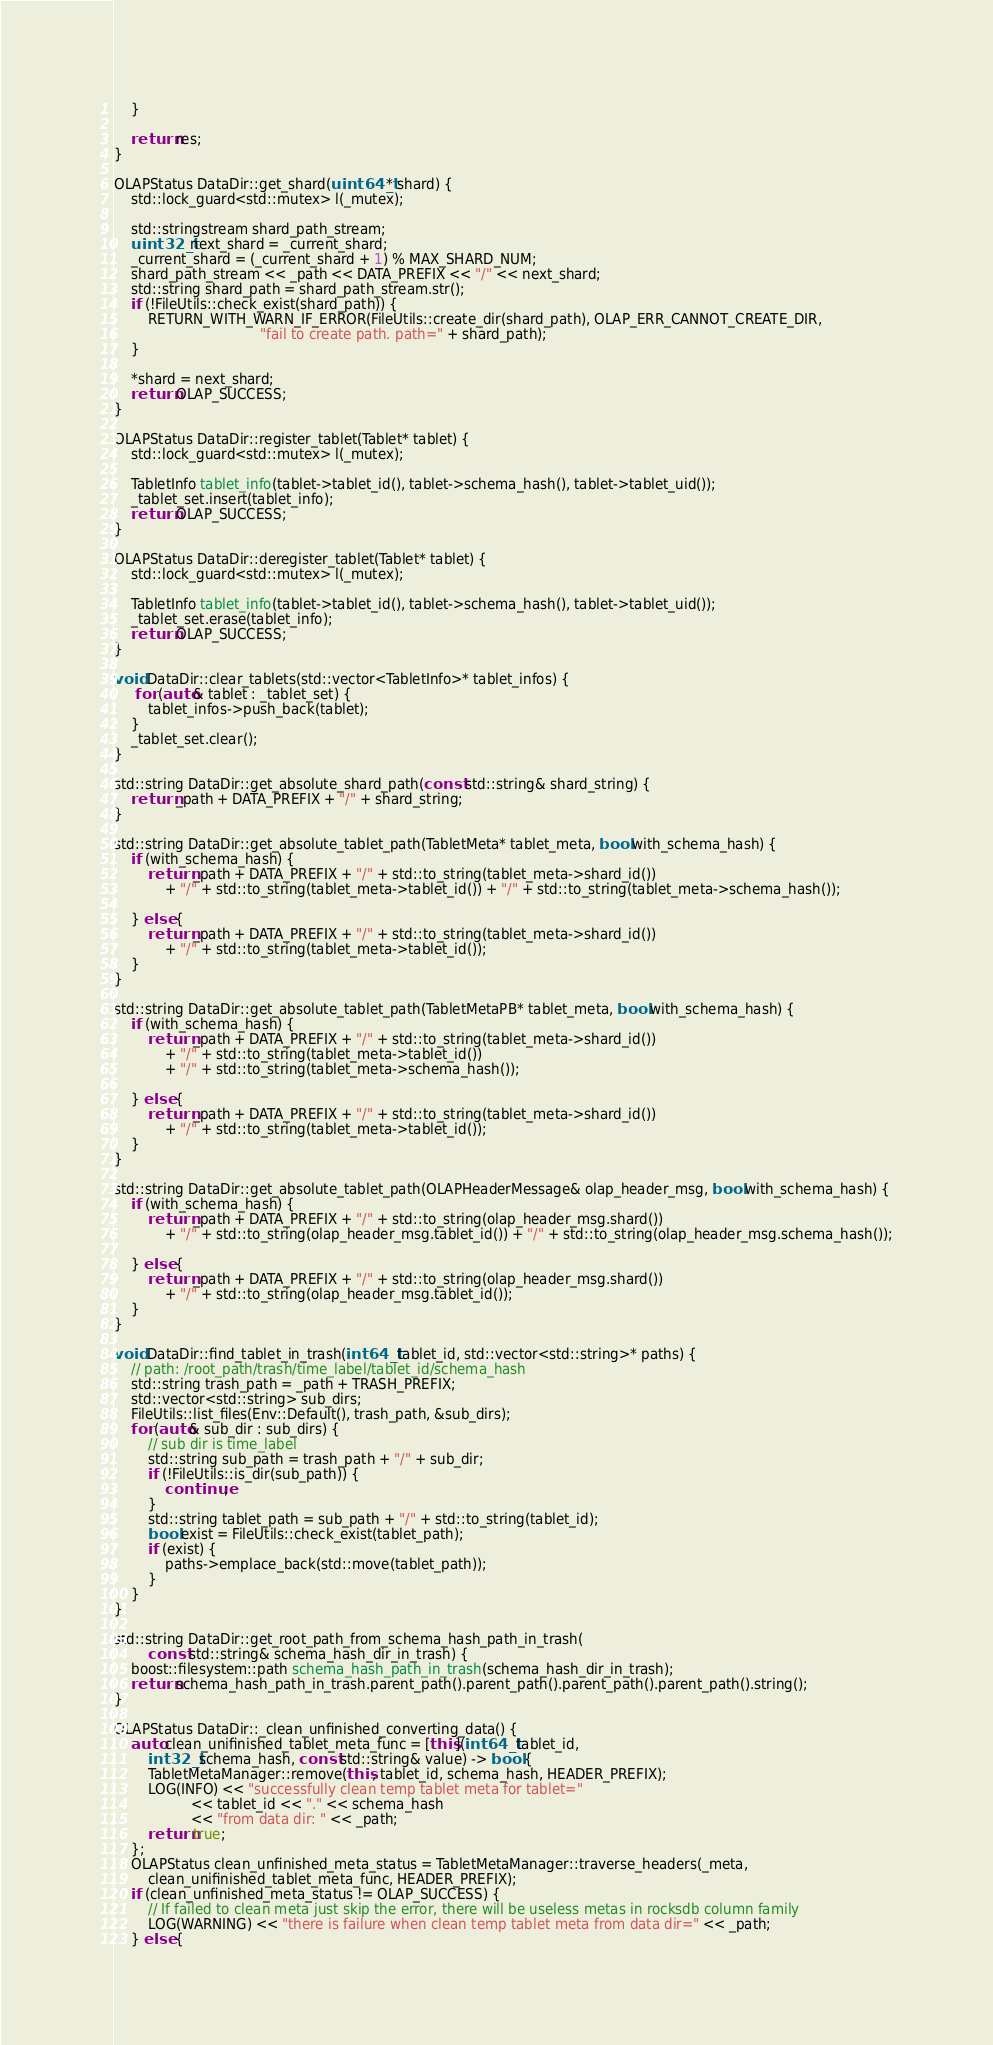Convert code to text. <code><loc_0><loc_0><loc_500><loc_500><_C++_>    }

    return res;
}

OLAPStatus DataDir::get_shard(uint64_t* shard) {
    std::lock_guard<std::mutex> l(_mutex);

    std::stringstream shard_path_stream;
    uint32_t next_shard = _current_shard;
    _current_shard = (_current_shard + 1) % MAX_SHARD_NUM;
    shard_path_stream << _path << DATA_PREFIX << "/" << next_shard;
    std::string shard_path = shard_path_stream.str();
    if (!FileUtils::check_exist(shard_path)) {
        RETURN_WITH_WARN_IF_ERROR(FileUtils::create_dir(shard_path), OLAP_ERR_CANNOT_CREATE_DIR,
                                  "fail to create path. path=" + shard_path);
    }

    *shard = next_shard;
    return OLAP_SUCCESS;
}

OLAPStatus DataDir::register_tablet(Tablet* tablet) {
    std::lock_guard<std::mutex> l(_mutex);

    TabletInfo tablet_info(tablet->tablet_id(), tablet->schema_hash(), tablet->tablet_uid());
    _tablet_set.insert(tablet_info);
    return OLAP_SUCCESS;
}

OLAPStatus DataDir::deregister_tablet(Tablet* tablet) {
    std::lock_guard<std::mutex> l(_mutex);

    TabletInfo tablet_info(tablet->tablet_id(), tablet->schema_hash(), tablet->tablet_uid());
    _tablet_set.erase(tablet_info);
    return OLAP_SUCCESS;
}

void DataDir::clear_tablets(std::vector<TabletInfo>* tablet_infos) {
     for (auto& tablet : _tablet_set) {
        tablet_infos->push_back(tablet);
    }
    _tablet_set.clear();
}

std::string DataDir::get_absolute_shard_path(const std::string& shard_string) {
    return _path + DATA_PREFIX + "/" + shard_string;
}

std::string DataDir::get_absolute_tablet_path(TabletMeta* tablet_meta, bool with_schema_hash) {
    if (with_schema_hash) {
        return _path + DATA_PREFIX + "/" + std::to_string(tablet_meta->shard_id())
            + "/" + std::to_string(tablet_meta->tablet_id()) + "/" + std::to_string(tablet_meta->schema_hash());

    } else {
        return _path + DATA_PREFIX + "/" + std::to_string(tablet_meta->shard_id())
            + "/" + std::to_string(tablet_meta->tablet_id());
    }
}

std::string DataDir::get_absolute_tablet_path(TabletMetaPB* tablet_meta, bool with_schema_hash) {
    if (with_schema_hash) {
        return _path + DATA_PREFIX + "/" + std::to_string(tablet_meta->shard_id())
            + "/" + std::to_string(tablet_meta->tablet_id())
            + "/" + std::to_string(tablet_meta->schema_hash());

    } else {
        return _path + DATA_PREFIX + "/" + std::to_string(tablet_meta->shard_id())
            + "/" + std::to_string(tablet_meta->tablet_id());
    }
}

std::string DataDir::get_absolute_tablet_path(OLAPHeaderMessage& olap_header_msg, bool with_schema_hash) {
    if (with_schema_hash) {
        return _path + DATA_PREFIX + "/" + std::to_string(olap_header_msg.shard())
            + "/" + std::to_string(olap_header_msg.tablet_id()) + "/" + std::to_string(olap_header_msg.schema_hash());

    } else {
        return _path + DATA_PREFIX + "/" + std::to_string(olap_header_msg.shard())
            + "/" + std::to_string(olap_header_msg.tablet_id());
    }
}

void DataDir::find_tablet_in_trash(int64_t tablet_id, std::vector<std::string>* paths) {
    // path: /root_path/trash/time_label/tablet_id/schema_hash
    std::string trash_path = _path + TRASH_PREFIX;
    std::vector<std::string> sub_dirs;
    FileUtils::list_files(Env::Default(), trash_path, &sub_dirs);
    for (auto& sub_dir : sub_dirs) {
        // sub dir is time_label
        std::string sub_path = trash_path + "/" + sub_dir;
        if (!FileUtils::is_dir(sub_path)) {
            continue;
        }
        std::string tablet_path = sub_path + "/" + std::to_string(tablet_id);
        bool exist = FileUtils::check_exist(tablet_path);
        if (exist) {
            paths->emplace_back(std::move(tablet_path));
        }
    }
}

std::string DataDir::get_root_path_from_schema_hash_path_in_trash(
        const std::string& schema_hash_dir_in_trash) {
    boost::filesystem::path schema_hash_path_in_trash(schema_hash_dir_in_trash);
    return schema_hash_path_in_trash.parent_path().parent_path().parent_path().parent_path().string();
}

OLAPStatus DataDir::_clean_unfinished_converting_data() {
    auto clean_unifinished_tablet_meta_func = [this](int64_t tablet_id,
        int32_t schema_hash, const std::string& value) -> bool {
        TabletMetaManager::remove(this, tablet_id, schema_hash, HEADER_PREFIX);
        LOG(INFO) << "successfully clean temp tablet meta for tablet="
                  << tablet_id << "." << schema_hash
                  << "from data dir: " << _path;
        return true;
    };
    OLAPStatus clean_unfinished_meta_status = TabletMetaManager::traverse_headers(_meta,
        clean_unifinished_tablet_meta_func, HEADER_PREFIX);
    if (clean_unfinished_meta_status != OLAP_SUCCESS) {
        // If failed to clean meta just skip the error, there will be useless metas in rocksdb column family
        LOG(WARNING) << "there is failure when clean temp tablet meta from data dir=" << _path;
    } else {</code> 